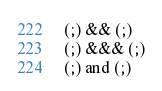Convert code to text. <code><loc_0><loc_0><loc_500><loc_500><_Elixir_>(;) && (;)
(;) &&& (;)
(;) and (;)</code> 